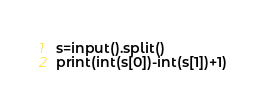Convert code to text. <code><loc_0><loc_0><loc_500><loc_500><_Python_>s=input().split()
print(int(s[0])-int(s[1])+1)</code> 